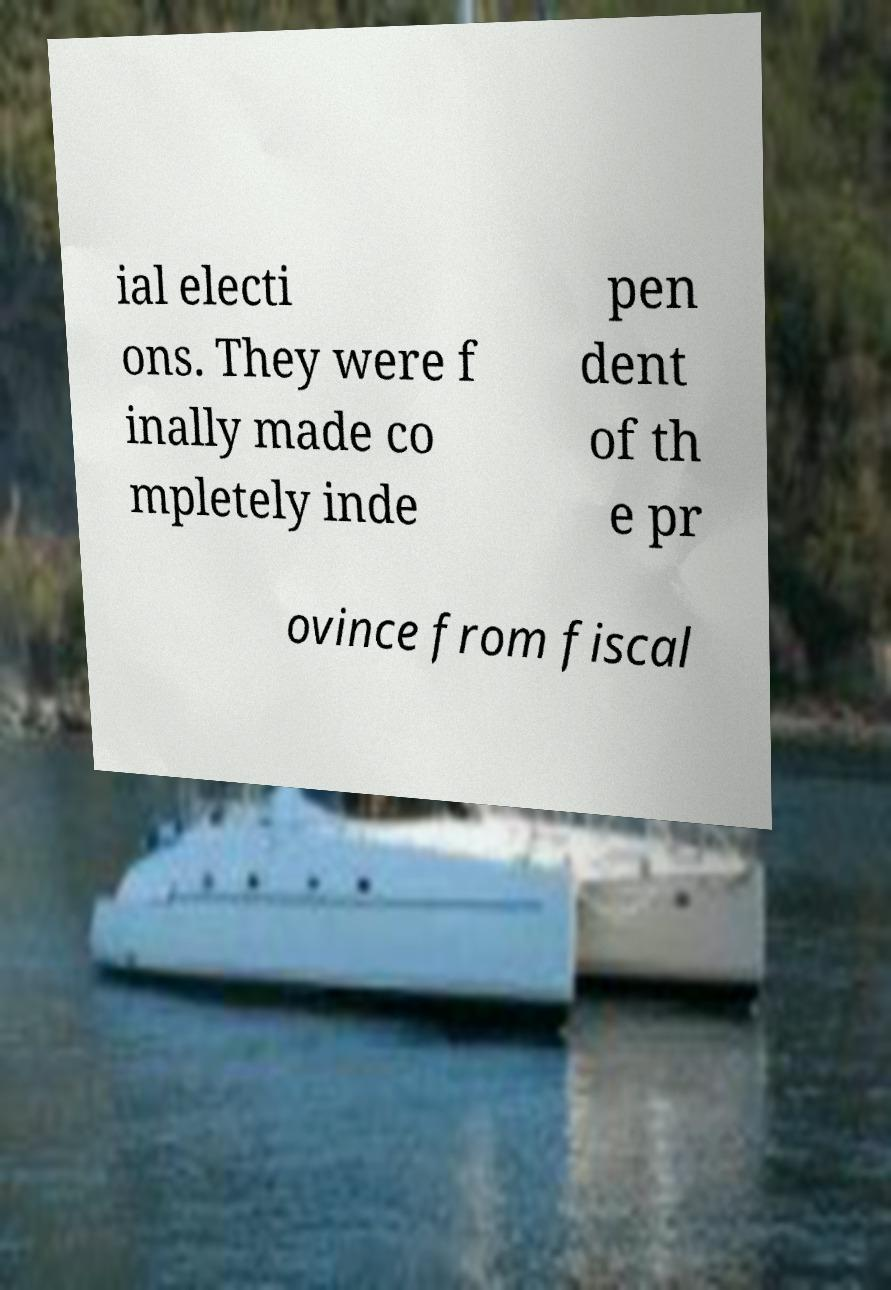Can you read and provide the text displayed in the image?This photo seems to have some interesting text. Can you extract and type it out for me? ial electi ons. They were f inally made co mpletely inde pen dent of th e pr ovince from fiscal 